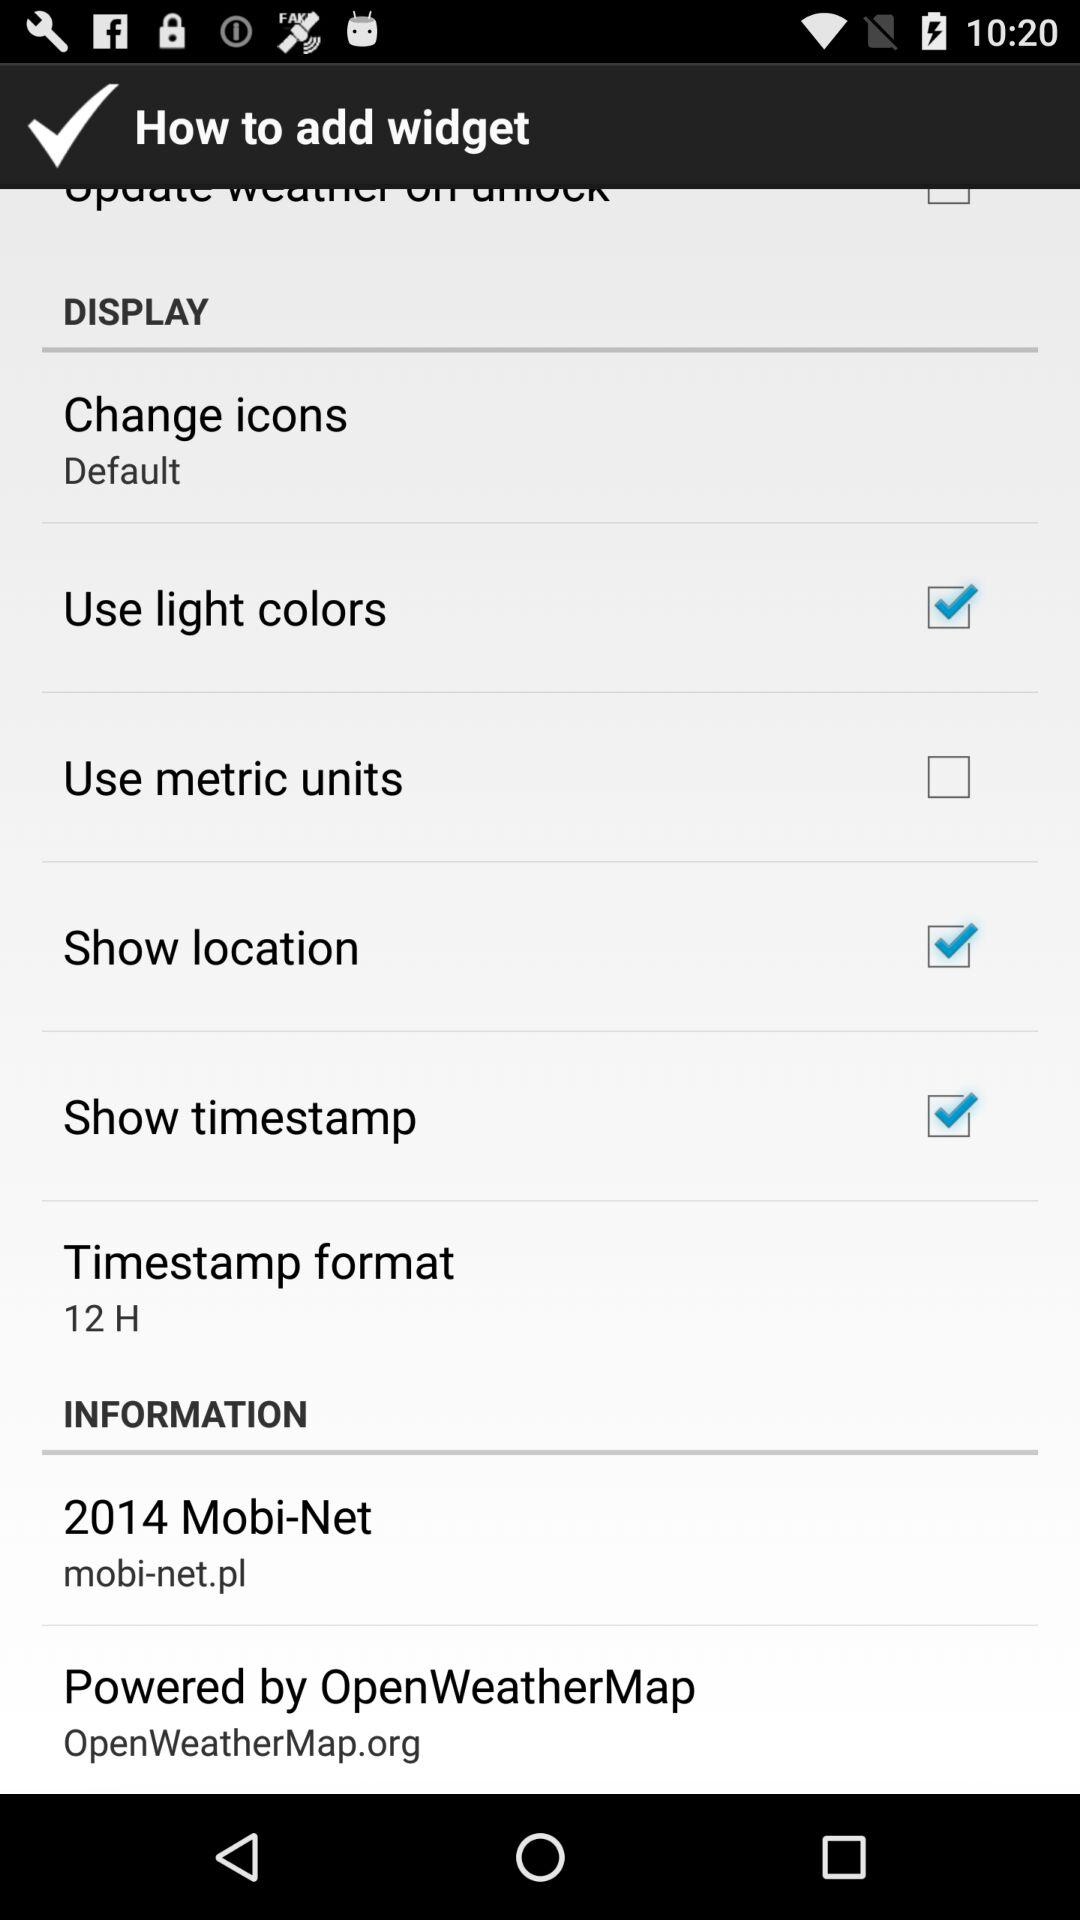What is the setting for "Change icons"? The setting for "Change icons" is "Default". 